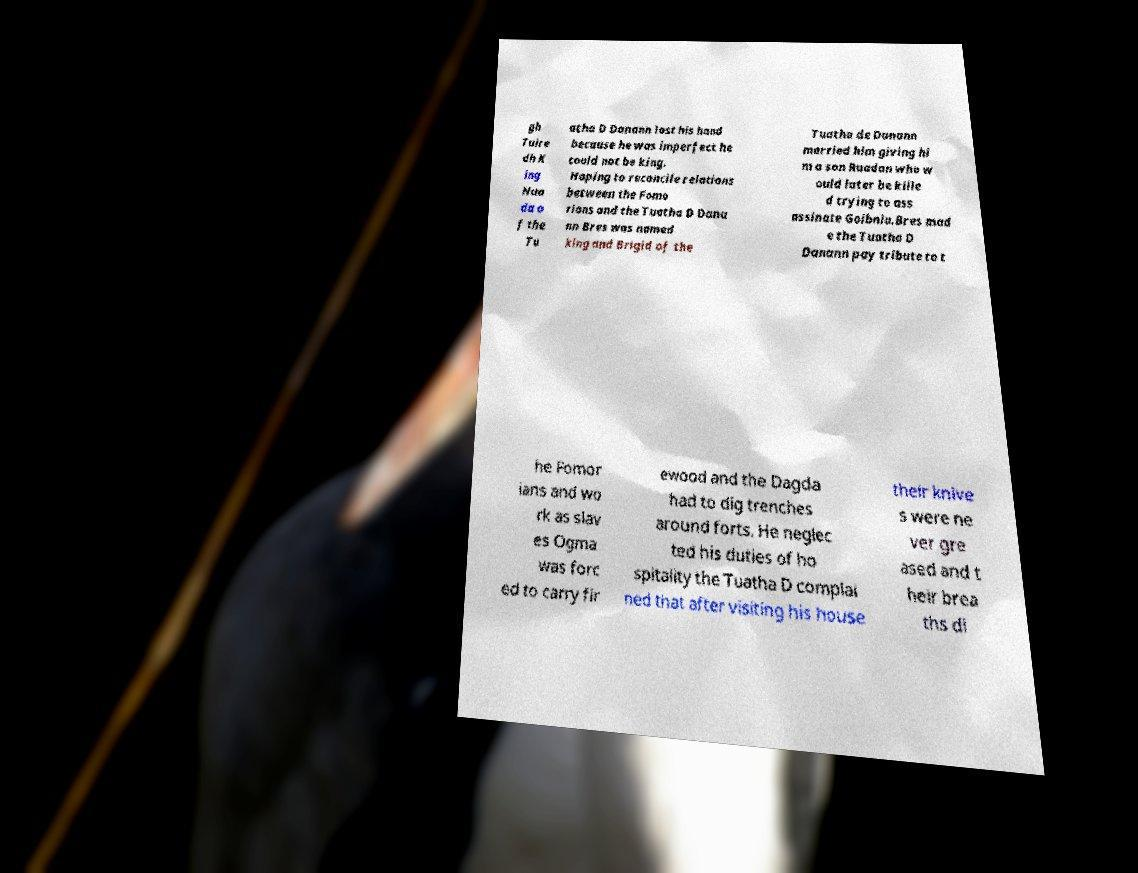Could you assist in decoding the text presented in this image and type it out clearly? gh Tuire dh K ing Nua da o f the Tu atha D Danann lost his hand because he was imperfect he could not be king. Hoping to reconcile relations between the Fomo rians and the Tuatha D Dana nn Bres was named king and Brigid of the Tuatha de Danann married him giving hi m a son Ruadan who w ould later be kille d trying to ass assinate Goibniu.Bres mad e the Tuatha D Danann pay tribute to t he Fomor ians and wo rk as slav es Ogma was forc ed to carry fir ewood and the Dagda had to dig trenches around forts. He neglec ted his duties of ho spitality the Tuatha D complai ned that after visiting his house their knive s were ne ver gre ased and t heir brea ths di 